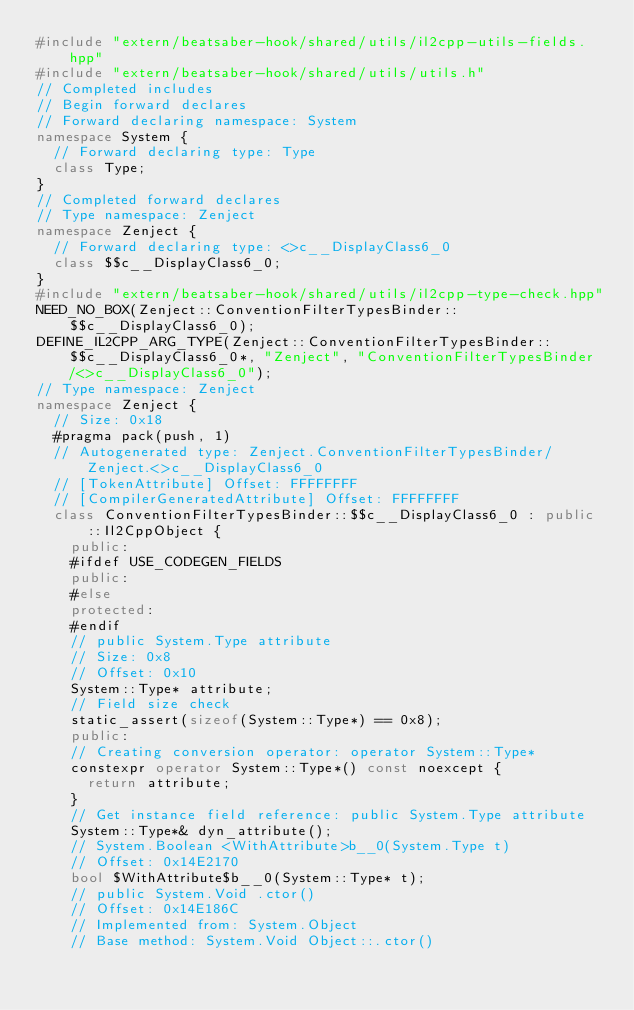Convert code to text. <code><loc_0><loc_0><loc_500><loc_500><_C++_>#include "extern/beatsaber-hook/shared/utils/il2cpp-utils-fields.hpp"
#include "extern/beatsaber-hook/shared/utils/utils.h"
// Completed includes
// Begin forward declares
// Forward declaring namespace: System
namespace System {
  // Forward declaring type: Type
  class Type;
}
// Completed forward declares
// Type namespace: Zenject
namespace Zenject {
  // Forward declaring type: <>c__DisplayClass6_0
  class $$c__DisplayClass6_0;
}
#include "extern/beatsaber-hook/shared/utils/il2cpp-type-check.hpp"
NEED_NO_BOX(Zenject::ConventionFilterTypesBinder::$$c__DisplayClass6_0);
DEFINE_IL2CPP_ARG_TYPE(Zenject::ConventionFilterTypesBinder::$$c__DisplayClass6_0*, "Zenject", "ConventionFilterTypesBinder/<>c__DisplayClass6_0");
// Type namespace: Zenject
namespace Zenject {
  // Size: 0x18
  #pragma pack(push, 1)
  // Autogenerated type: Zenject.ConventionFilterTypesBinder/Zenject.<>c__DisplayClass6_0
  // [TokenAttribute] Offset: FFFFFFFF
  // [CompilerGeneratedAttribute] Offset: FFFFFFFF
  class ConventionFilterTypesBinder::$$c__DisplayClass6_0 : public ::Il2CppObject {
    public:
    #ifdef USE_CODEGEN_FIELDS
    public:
    #else
    protected:
    #endif
    // public System.Type attribute
    // Size: 0x8
    // Offset: 0x10
    System::Type* attribute;
    // Field size check
    static_assert(sizeof(System::Type*) == 0x8);
    public:
    // Creating conversion operator: operator System::Type*
    constexpr operator System::Type*() const noexcept {
      return attribute;
    }
    // Get instance field reference: public System.Type attribute
    System::Type*& dyn_attribute();
    // System.Boolean <WithAttribute>b__0(System.Type t)
    // Offset: 0x14E2170
    bool $WithAttribute$b__0(System::Type* t);
    // public System.Void .ctor()
    // Offset: 0x14E186C
    // Implemented from: System.Object
    // Base method: System.Void Object::.ctor()</code> 